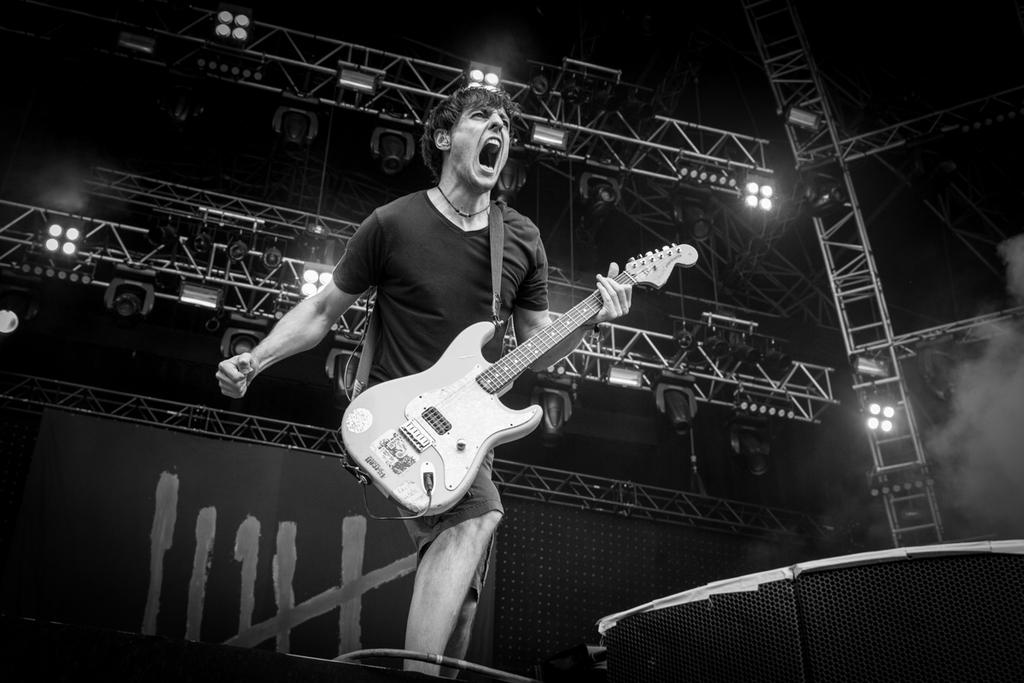What is the man in the image doing? The man is playing a guitar. What is the man's emotional state in the image? The man is shouting. What can be seen in the background of the image? There are lights and poles in the background of the image. How many icicles are hanging from the guitar in the image? There are no icicles present in the image, as it is not a cold environment and the guitar is not made of a material that would support icicles. 